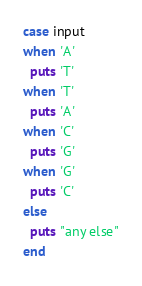Convert code to text. <code><loc_0><loc_0><loc_500><loc_500><_Ruby_>case input
when 'A'
  puts 'T'
when 'T'
  puts 'A'
when 'C'
  puts 'G'
when 'G'
  puts 'C'
else
  puts "any else"
end</code> 